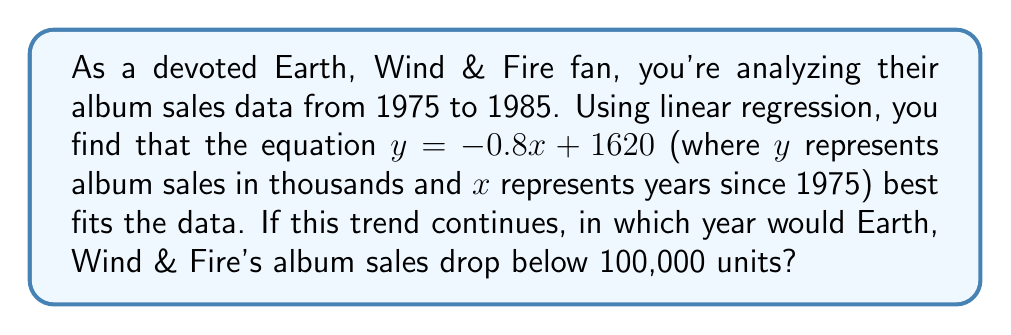Can you answer this question? Let's approach this step-by-step:

1) We have the linear regression equation: $y = -0.8x + 1620$
   Where $y$ is album sales in thousands and $x$ is years since 1975.

2) We want to find when $y < 100$ (since sales are in thousands).

3) Let's set up the inequality:
   $-0.8x + 1620 < 100$

4) Solve for $x$:
   $-0.8x < -1520$
   $x > 1900$

5) So, 1900 years after 1975 is when sales would drop below 100,000.

6) Calculate the actual year:
   $1975 + 1900 = 3875$

Therefore, if this trend were to continue (which is unlikely in reality), Earth, Wind & Fire's album sales would drop below 100,000 units in the year 3875.
Answer: 3875 